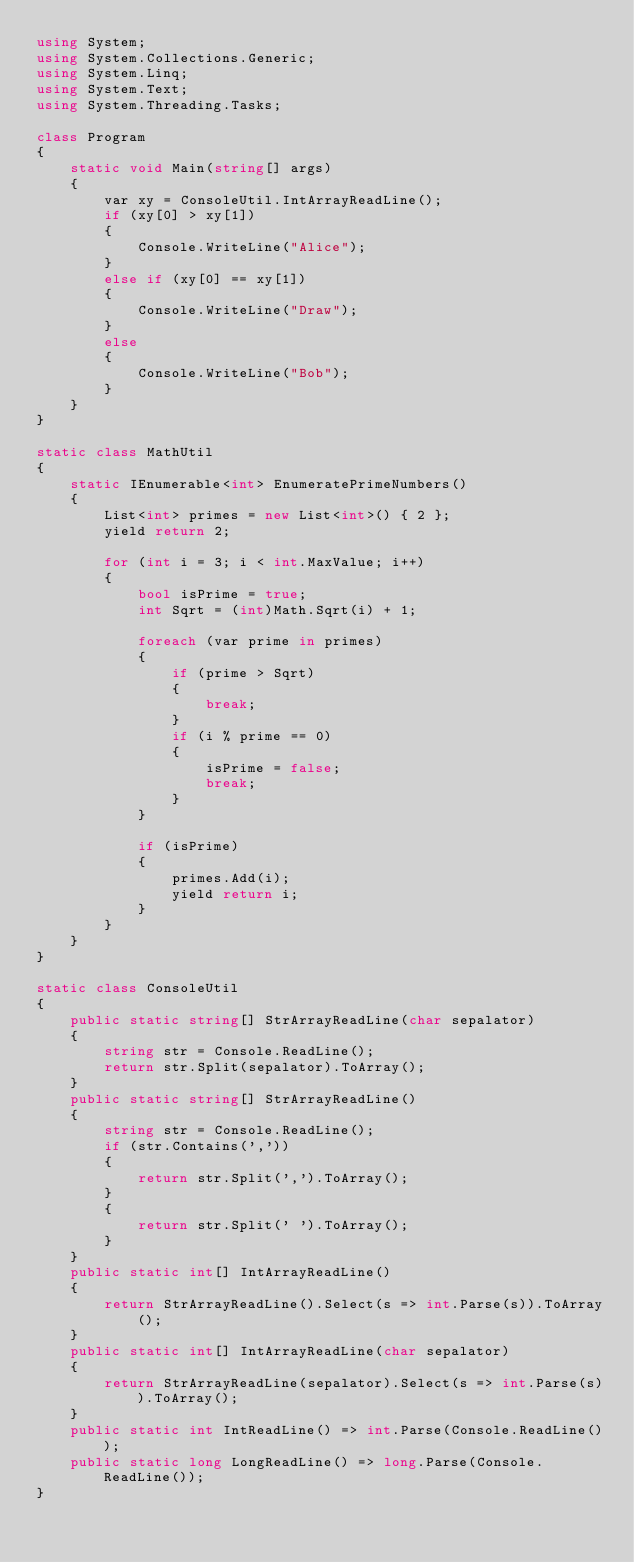Convert code to text. <code><loc_0><loc_0><loc_500><loc_500><_C#_>using System;
using System.Collections.Generic;
using System.Linq;
using System.Text;
using System.Threading.Tasks;

class Program
{
    static void Main(string[] args)
    {
        var xy = ConsoleUtil.IntArrayReadLine();
        if (xy[0] > xy[1])
        {
            Console.WriteLine("Alice");
        }
        else if (xy[0] == xy[1])
        {
            Console.WriteLine("Draw");
        }
        else
        {
            Console.WriteLine("Bob");
        }
    }
}

static class MathUtil
{
    static IEnumerable<int> EnumeratePrimeNumbers()
    {
        List<int> primes = new List<int>() { 2 };
        yield return 2;

        for (int i = 3; i < int.MaxValue; i++)
        {
            bool isPrime = true;
            int Sqrt = (int)Math.Sqrt(i) + 1;

            foreach (var prime in primes)
            {
                if (prime > Sqrt)
                {
                    break;
                }
                if (i % prime == 0)
                {
                    isPrime = false;
                    break;
                }
            }

            if (isPrime)
            {
                primes.Add(i);
                yield return i;
            }
        }
    }
}

static class ConsoleUtil
{
    public static string[] StrArrayReadLine(char sepalator)
    {
        string str = Console.ReadLine();
        return str.Split(sepalator).ToArray();
    }
    public static string[] StrArrayReadLine()
    {
        string str = Console.ReadLine();
        if (str.Contains(','))
        {
            return str.Split(',').ToArray();
        }
        {
            return str.Split(' ').ToArray();
        }
    }
    public static int[] IntArrayReadLine()
    {
        return StrArrayReadLine().Select(s => int.Parse(s)).ToArray();
    }
    public static int[] IntArrayReadLine(char sepalator)
    {
        return StrArrayReadLine(sepalator).Select(s => int.Parse(s)).ToArray();
    }
    public static int IntReadLine() => int.Parse(Console.ReadLine());
    public static long LongReadLine() => long.Parse(Console.ReadLine());
}</code> 